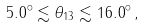Convert formula to latex. <formula><loc_0><loc_0><loc_500><loc_500>5 . 0 ^ { \circ } \lesssim \theta _ { 1 3 } \lesssim 1 6 . 0 ^ { \circ } \, ,</formula> 